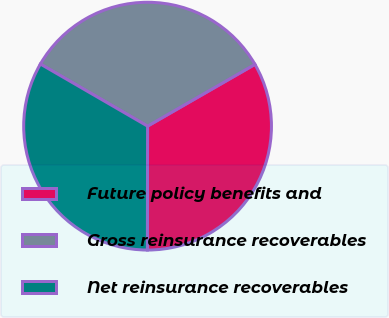<chart> <loc_0><loc_0><loc_500><loc_500><pie_chart><fcel>Future policy benefits and<fcel>Gross reinsurance recoverables<fcel>Net reinsurance recoverables<nl><fcel>33.33%<fcel>33.33%<fcel>33.33%<nl></chart> 